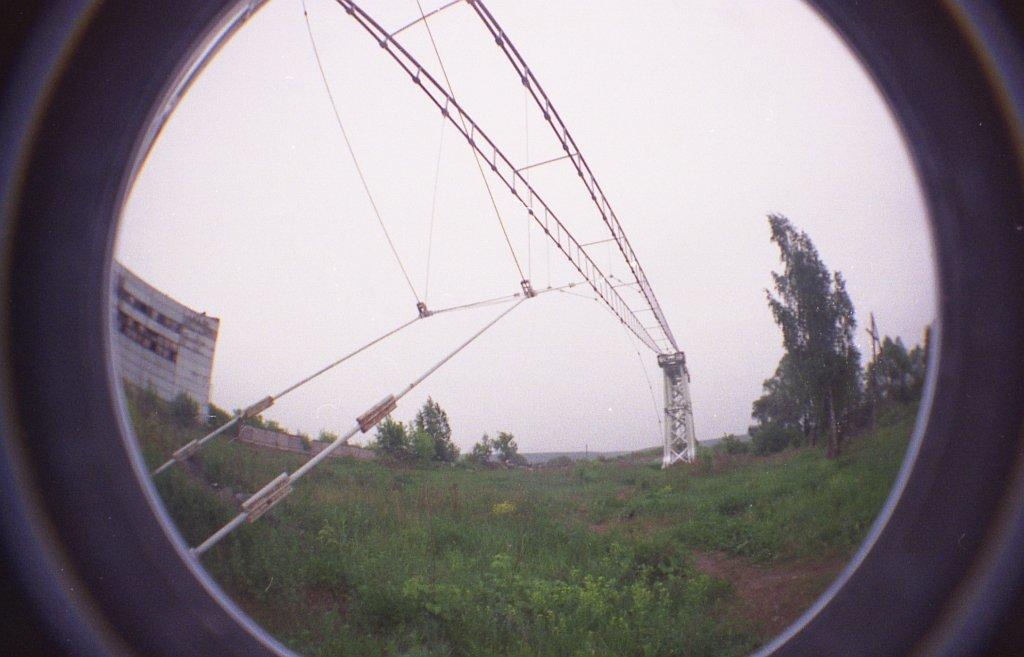What is the medium through which the image is viewed? The image is viewed through a glass. What type of surface can be seen in the image? There is ground visible in the image. What is present on the ground in the image? There are objects on the ground in the image. What type of vegetation is visible in the image? There is grass, plants, and trees in the image. What type of structure is present in the image? There is a building in the image. What type of materials are present in the image? There are metal objects in the image. What part of the natural environment is visible in the image? The sky is visible in the image. What type of fruit is hanging from the tree in the image? There is no fruit visible in the image; only trees are present. How does the skate interact with the building in the image? There is no skate present in the image; it is not possible to answer this question. 